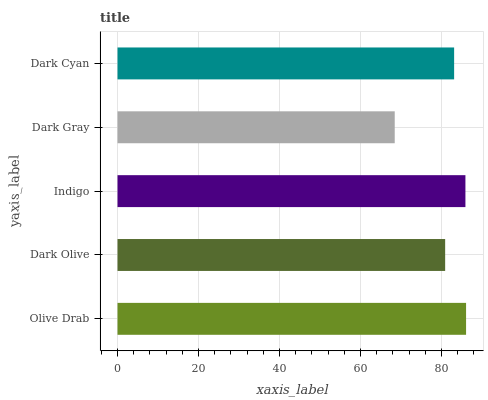Is Dark Gray the minimum?
Answer yes or no. Yes. Is Olive Drab the maximum?
Answer yes or no. Yes. Is Dark Olive the minimum?
Answer yes or no. No. Is Dark Olive the maximum?
Answer yes or no. No. Is Olive Drab greater than Dark Olive?
Answer yes or no. Yes. Is Dark Olive less than Olive Drab?
Answer yes or no. Yes. Is Dark Olive greater than Olive Drab?
Answer yes or no. No. Is Olive Drab less than Dark Olive?
Answer yes or no. No. Is Dark Cyan the high median?
Answer yes or no. Yes. Is Dark Cyan the low median?
Answer yes or no. Yes. Is Dark Gray the high median?
Answer yes or no. No. Is Olive Drab the low median?
Answer yes or no. No. 